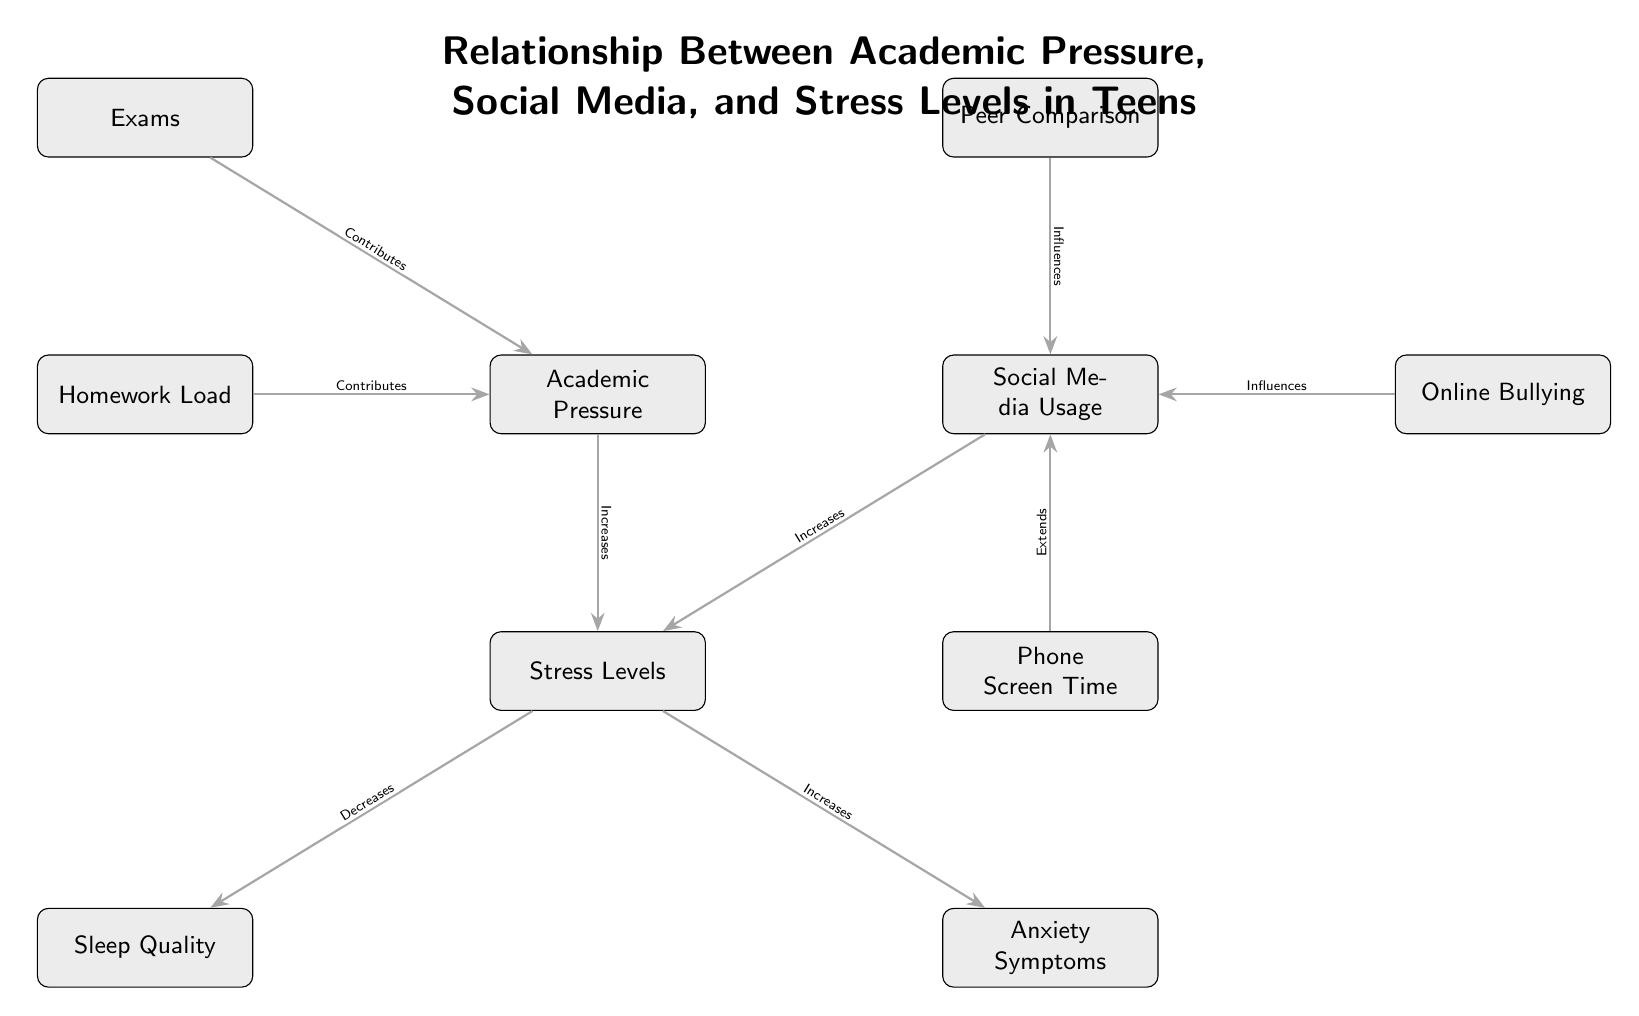What are the main nodes in the diagram? The main nodes in the diagram are Academic Pressure, Social Media Usage, Stress Levels, Sleep Quality, Anxiety Symptoms, Exams, Homework Load, Peer Comparison, Online Bullying, and Phone Screen Time. These nodes represent key factors affecting stress and mental health in teens.
Answer: Academic Pressure, Social Media Usage, Stress Levels, Sleep Quality, Anxiety Symptoms, Exams, Homework Load, Peer Comparison, Online Bullying, Phone Screen Time How many edges are in the diagram? By counting the connections between nodes, the diagram contains a total of 8 edges, illustrating the relationships between the factors affecting stress levels in teens.
Answer: 8 Which factor directly influences Stress Levels? Stress Levels are directly influenced by both Academic Pressure and Social Media Usage, as indicated by the arrows pointing to Stress Levels from these two nodes.
Answer: Academic Pressure, Social Media Usage What is the effect of Stress Levels on Sleep Quality? According to the diagram, Stress Levels decrease Sleep Quality, which is shown by the arrow leading from Stress Levels to Sleep Quality labeled as "Decreases."
Answer: Decreases Which factors contribute to Academic Pressure? The factors that contribute to Academic Pressure are Exams and Homework Load, as indicated by the arrows showing a contribution relationship between these nodes and Academic Pressure.
Answer: Exams, Homework Load How does Online Bullying affect Social Media Usage? Online Bullying influences Social Media Usage, illustrating that experiences with online bullying can impact the amount and nature of social media interaction for teens.
Answer: Influences Which nodes are related to Anxiety Symptoms? Anxiety Symptoms are related to Stress Levels, with an arrow indicating that Stress Levels increase the symptoms. This shows the link between high stress and anxiety in teens.
Answer: Stress Levels What kind of relationship exists between Peer Comparison and Social Media Usage? The relationship between Peer Comparison and Social Media Usage is that Peer Comparison influences Social Media Usage, suggesting that comparing oneself to peers affects how teens use social media.
Answer: Influences 